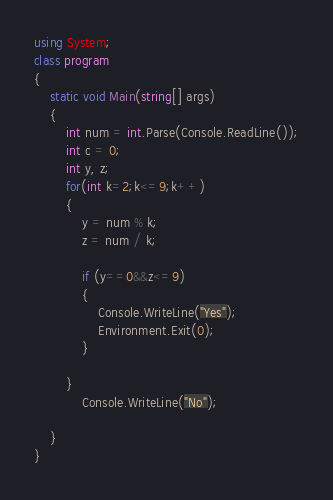<code> <loc_0><loc_0><loc_500><loc_500><_C#_>using System;
class program
{
    static void Main(string[] args)
    {
        int num = int.Parse(Console.ReadLine());
        int c = 0;
        int y, z;
        for(int k=2;k<=9;k++)
        {
            y = num % k;
            z = num / k;

            if (y==0&&z<=9)
            {
                Console.WriteLine("Yes");
                Environment.Exit(0);
            }

        }
            Console.WriteLine("No");
        
    }
}</code> 